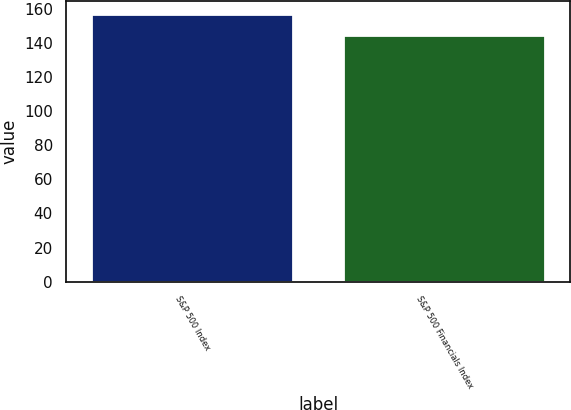Convert chart to OTSL. <chart><loc_0><loc_0><loc_500><loc_500><bar_chart><fcel>S&P 500 Index<fcel>S&P 500 Financials Index<nl><fcel>156.78<fcel>144.78<nl></chart> 